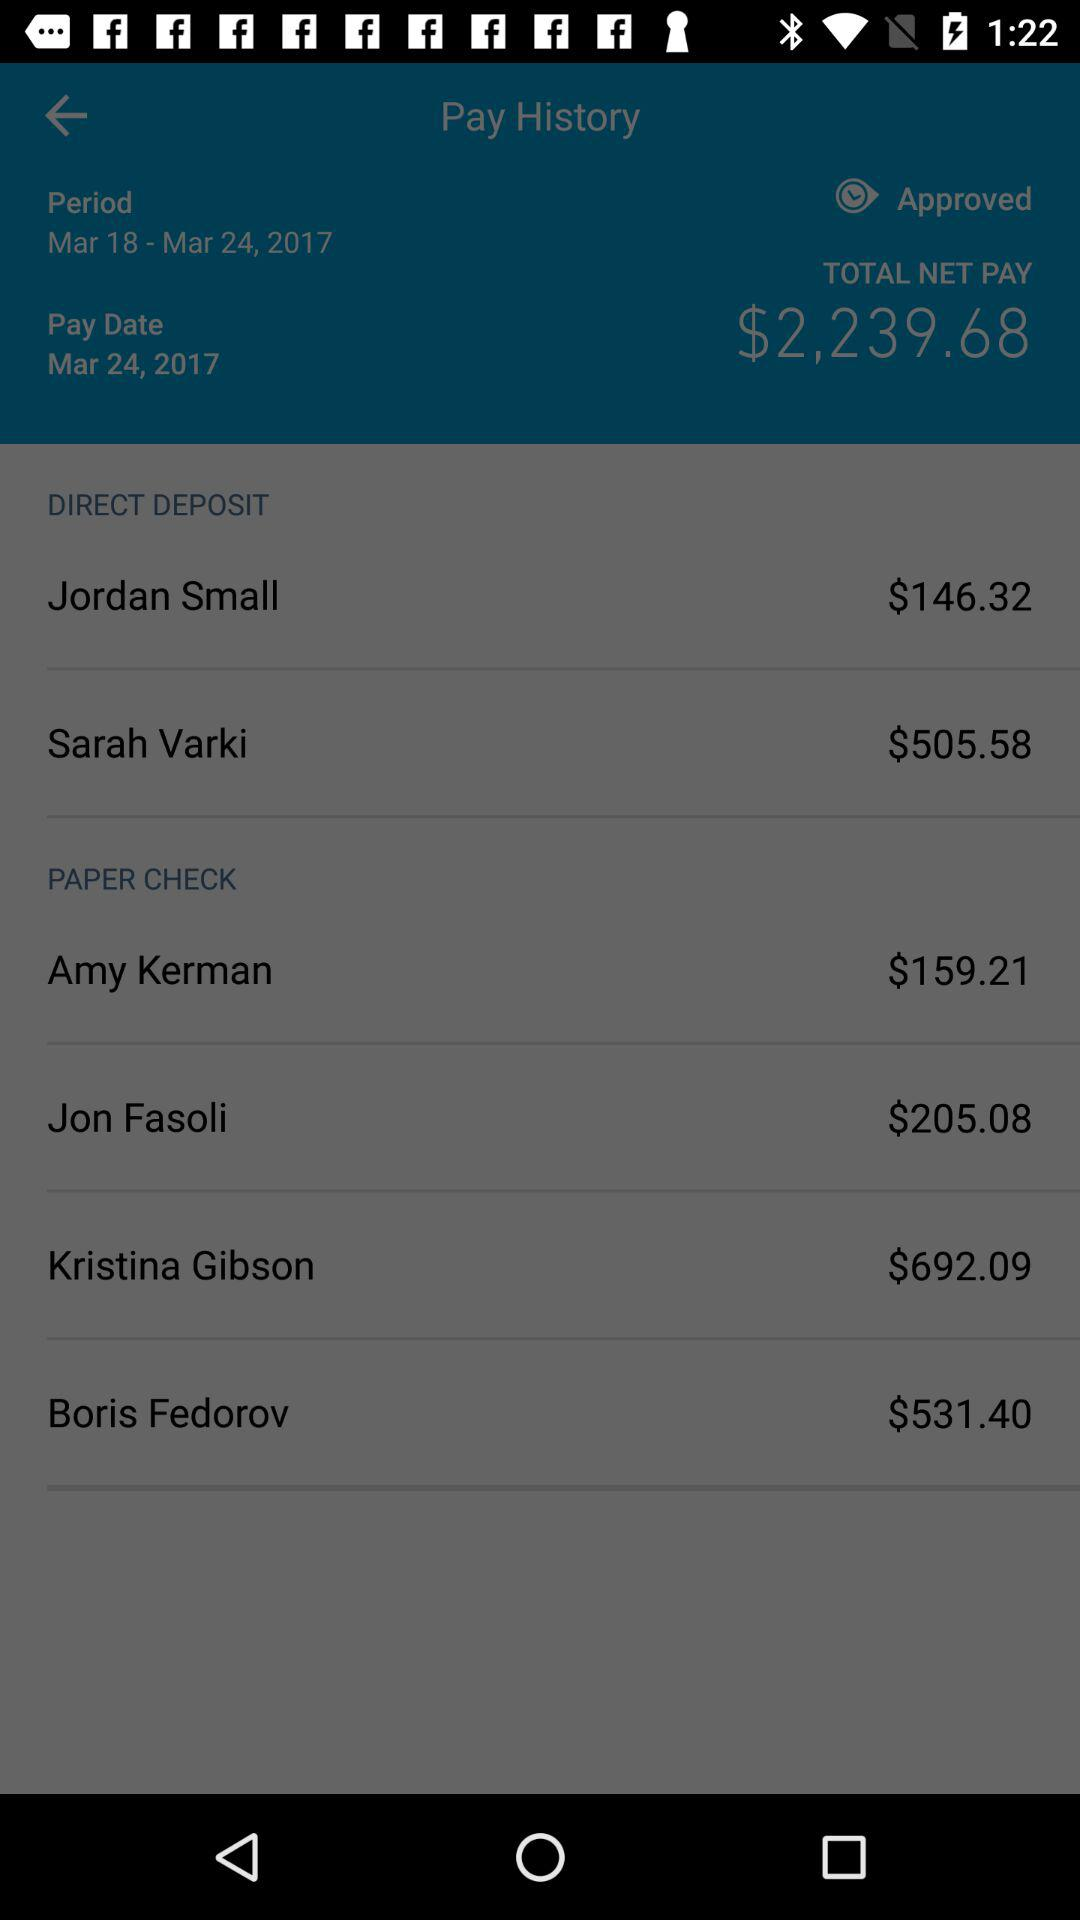What amount is mentioned for Jon Fasoli in "PAPER CHECK"? The mentioned amount for Jon Fasoli in "PAPER CHECK" is $205.08. 